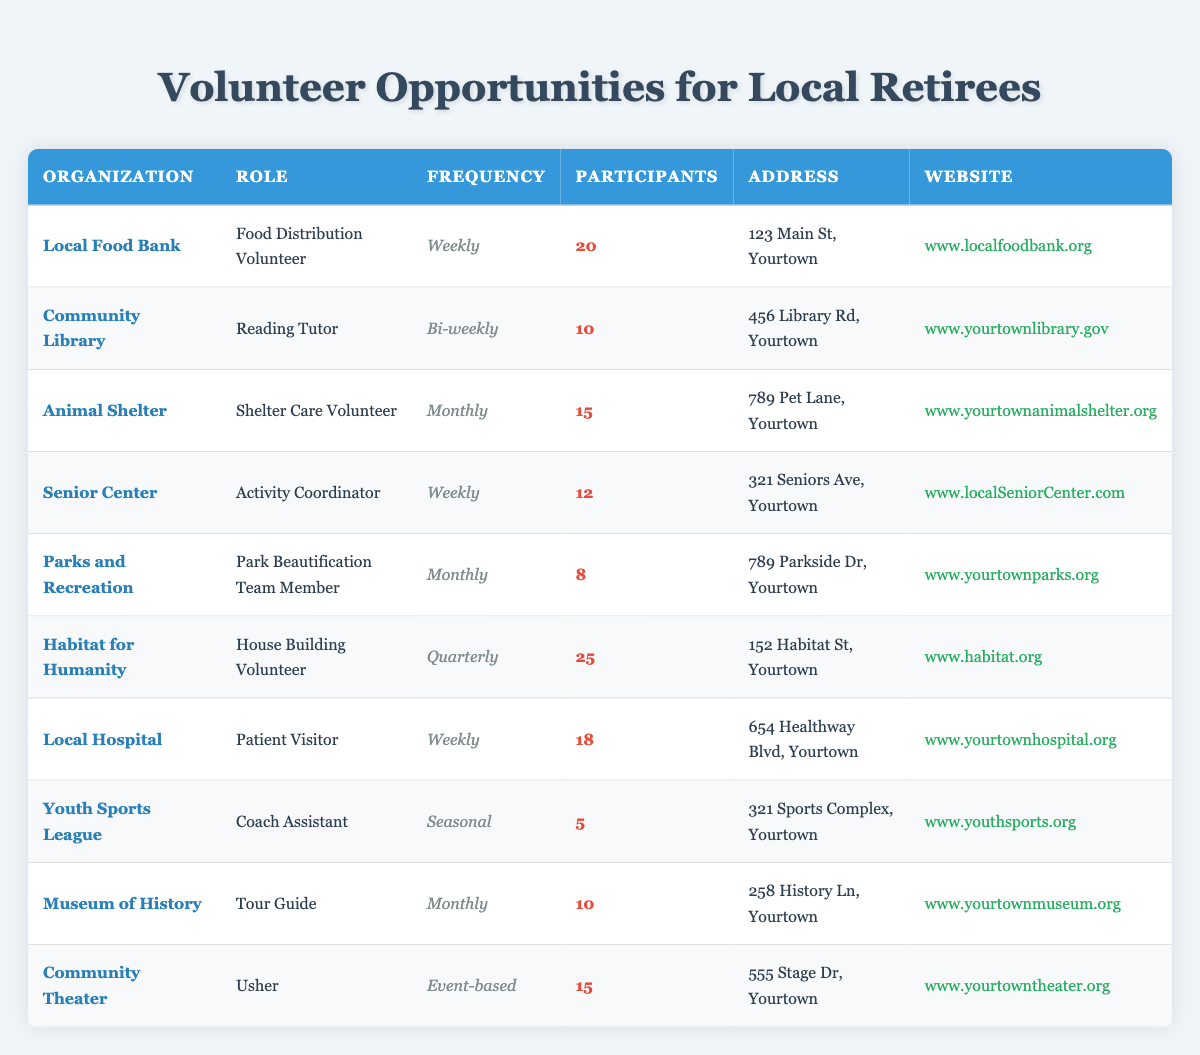What is the role of volunteers at the Community Library? According to the table, the role of volunteers at the Community Library is a Reading Tutor.
Answer: Reading Tutor How many participants are involved in the Habitat for Humanity's House Building Volunteer program? The table indicates that there are 25 participants involved in the Habitat for Humanity's House Building Volunteer program.
Answer: 25 Which organization has the most participants and what is the frequency of that role? Habitat for Humanity has the most participants (25), and the frequency of that role is Quarterly.
Answer: Habitat for Humanity, Quarterly Is there a volunteer opportunity at the Youth Sports League? Yes, there is a volunteer opportunity at the Youth Sports League for a Coach Assistant.
Answer: Yes What is the average number of participants among the volunteer opportunities listed? To find the average, we first add the number of participants: 20 + 10 + 15 + 12 + 8 + 25 + 18 + 5 + 10 + 15 =  143. Then divide by the number of opportunities (10): 143 / 10 = 14.3.
Answer: 14.3 Which organization has a volunteer role that occurs on a monthly basis and how many participants are involved? The Animal Shelter and the Museum of History both have volunteer roles that occur on a monthly basis. The Animal Shelter has 15 participants, and the Museum of History has 10 participants.
Answer: Animal Shelter: 15 participants, Museum of History: 10 participants How many organizations offer weekly volunteer opportunities? Reviewing the table, there are four organizations that offer weekly volunteer opportunities: Local Food Bank, Senior Center, Local Hospital, and Youth Sports League.
Answer: 4 What is the total number of participants in the monthly volunteer opportunities? The organizations with monthly opportunities are the Animal Shelter, Parks and Recreation, and Museum of History. Their respective participants are 15, 8, and 10. Adding these gives: 15 + 8 + 10 = 33 participants.
Answer: 33 Are there more participants in the Local Food Bank than in the Community Theater? Yes, the Local Food Bank has 20 participants, while the Community Theater has 15 participants.
Answer: Yes 